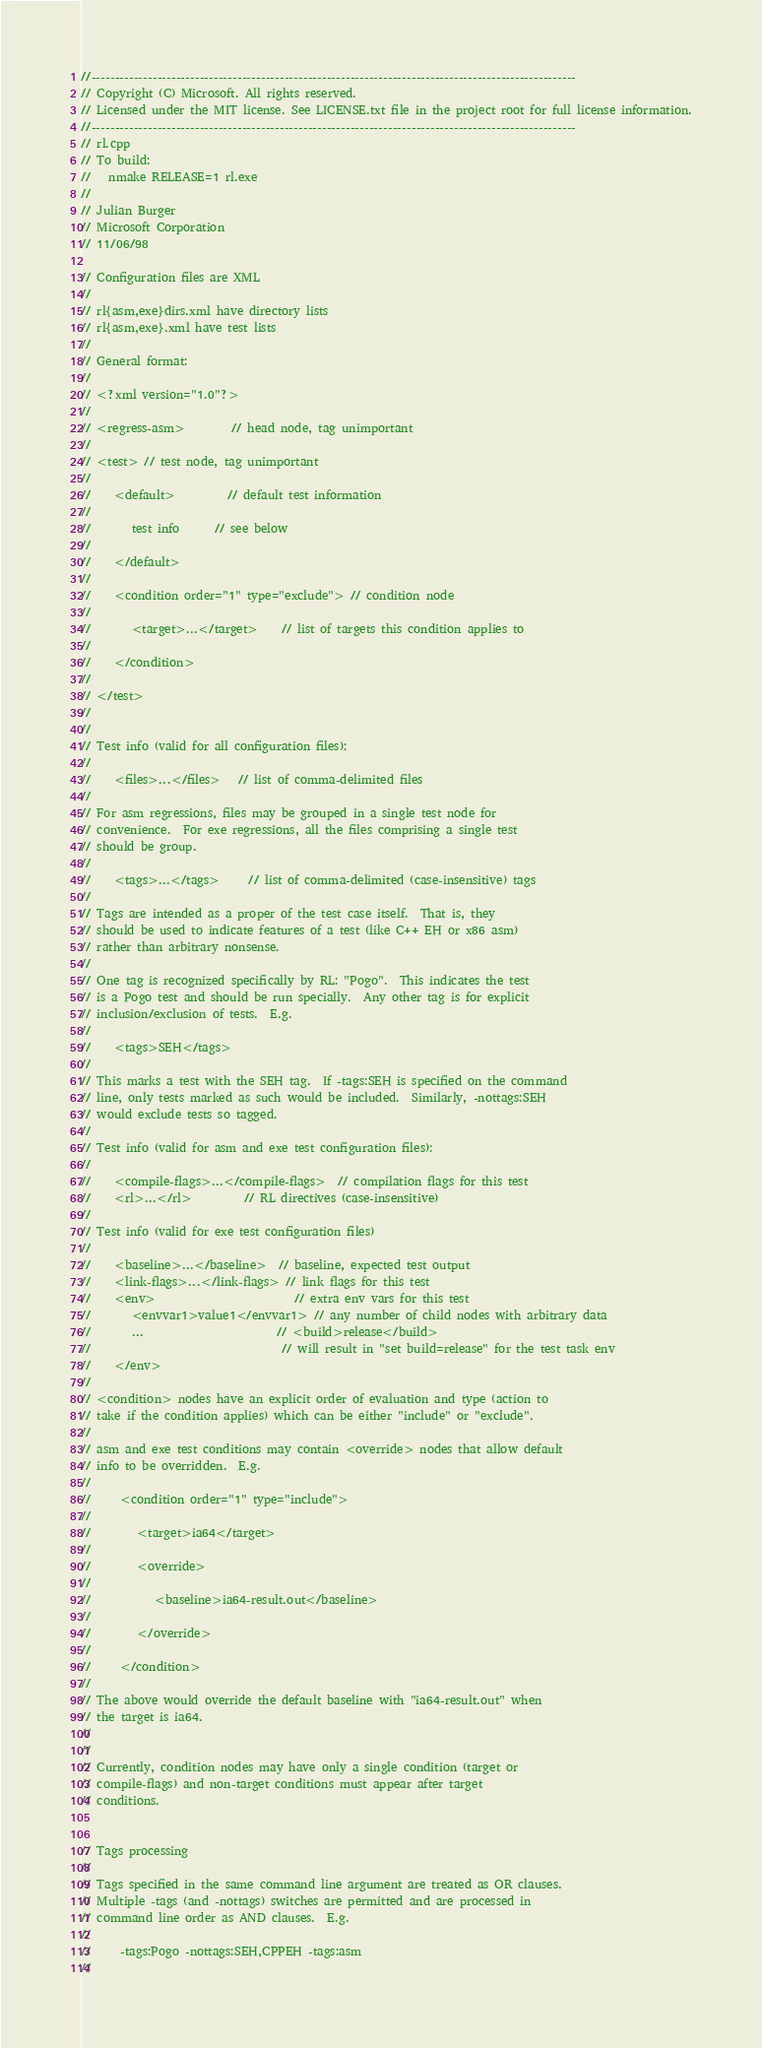Convert code to text. <code><loc_0><loc_0><loc_500><loc_500><_C++_>//-------------------------------------------------------------------------------------------------------
// Copyright (C) Microsoft. All rights reserved.
// Licensed under the MIT license. See LICENSE.txt file in the project root for full license information.
//-------------------------------------------------------------------------------------------------------
// rl.cpp
// To build:
//   nmake RELEASE=1 rl.exe
//
// Julian Burger
// Microsoft Corporation
// 11/06/98

// Configuration files are XML
//
// rl{asm,exe}dirs.xml have directory lists
// rl{asm,exe}.xml have test lists
//
// General format:
//
// <?xml version="1.0"?>
//
// <regress-asm>        // head node, tag unimportant
//
// <test> // test node, tag unimportant
//
//    <default>         // default test information
//
//       test info      // see below
//
//    </default>
//
//    <condition order="1" type="exclude"> // condition node
//
//       <target>...</target>    // list of targets this condition applies to
//
//    </condition>
//
// </test>
//
//
// Test info (valid for all configuration files):
//
//    <files>...</files>   // list of comma-delimited files
//
// For asm regressions, files may be grouped in a single test node for
// convenience.  For exe regressions, all the files comprising a single test
// should be group.
//
//    <tags>...</tags>     // list of comma-delimited (case-insensitive) tags
//
// Tags are intended as a proper of the test case itself.  That is, they
// should be used to indicate features of a test (like C++ EH or x86 asm)
// rather than arbitrary nonsense.
//
// One tag is recognized specifically by RL: "Pogo".  This indicates the test
// is a Pogo test and should be run specially.  Any other tag is for explicit
// inclusion/exclusion of tests.  E.g.
//
//    <tags>SEH</tags>
//
// This marks a test with the SEH tag.  If -tags:SEH is specified on the command
// line, only tests marked as such would be included.  Similarly, -nottags:SEH
// would exclude tests so tagged.
//
// Test info (valid for asm and exe test configuration files):
//
//    <compile-flags>...</compile-flags>  // compilation flags for this test
//    <rl>...</rl>         // RL directives (case-insensitive)
//
// Test info (valid for exe test configuration files)
//
//    <baseline>...</baseline>  // baseline, expected test output
//    <link-flags>...</link-flags> // link flags for this test
//    <env>                        // extra env vars for this test
//       <envvar1>value1</envvar1> // any number of child nodes with arbitrary data
//       ...                       // <build>release</build>
//                                 // will result in "set build=release" for the test task env
//    </env>
//
// <condition> nodes have an explicit order of evaluation and type (action to
// take if the condition applies) which can be either "include" or "exclude".
//
// asm and exe test conditions may contain <override> nodes that allow default
// info to be overridden.  E.g.
//
//     <condition order="1" type="include">
//
//        <target>ia64</target>
//
//        <override>
//
//           <baseline>ia64-result.out</baseline>
//
//        </override>
//
//     </condition>
//
// The above would override the default baseline with "ia64-result.out" when
// the target is ia64.
//
//
// Currently, condition nodes may have only a single condition (target or
// compile-flags) and non-target conditions must appear after target
// conditions.


// Tags processing
//
// Tags specified in the same command line argument are treated as OR clauses.
// Multiple -tags (and -nottags) switches are permitted and are processed in
// command line order as AND clauses.  E.g.
//
//     -tags:Pogo -nottags:SEH,CPPEH -tags:asm
//</code> 